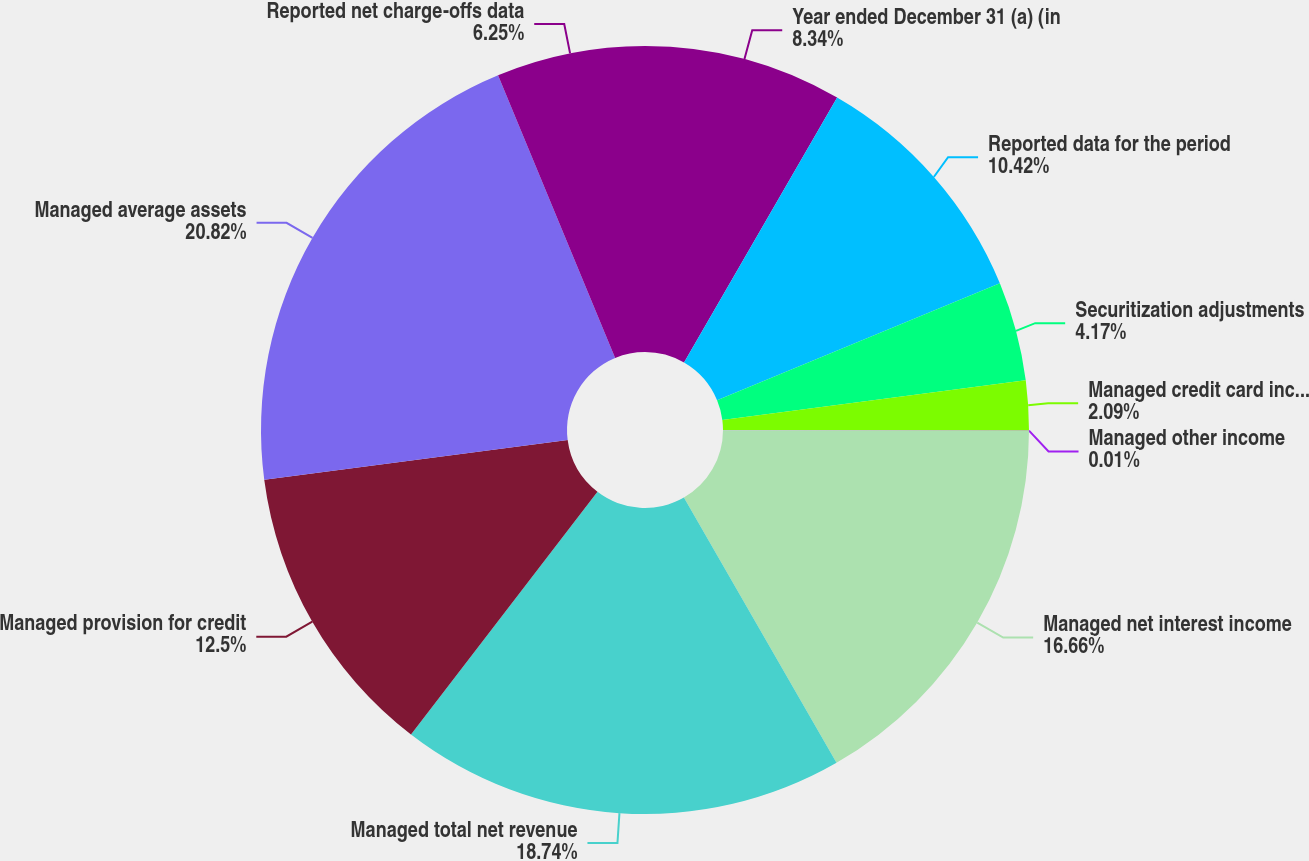Convert chart. <chart><loc_0><loc_0><loc_500><loc_500><pie_chart><fcel>Year ended December 31 (a) (in<fcel>Reported data for the period<fcel>Securitization adjustments<fcel>Managed credit card income<fcel>Managed other income<fcel>Managed net interest income<fcel>Managed total net revenue<fcel>Managed provision for credit<fcel>Managed average assets<fcel>Reported net charge-offs data<nl><fcel>8.34%<fcel>10.42%<fcel>4.17%<fcel>2.09%<fcel>0.01%<fcel>16.66%<fcel>18.74%<fcel>12.5%<fcel>20.82%<fcel>6.25%<nl></chart> 